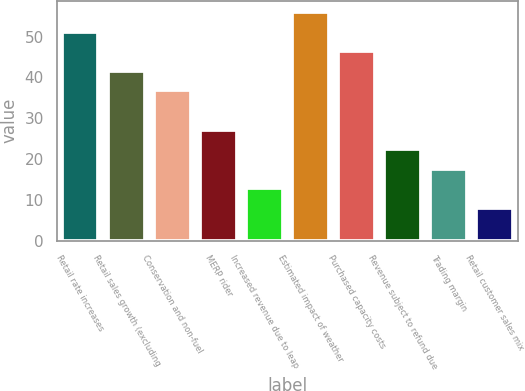Convert chart. <chart><loc_0><loc_0><loc_500><loc_500><bar_chart><fcel>Retail rate increases<fcel>Retail sales growth (excluding<fcel>Conservation and non-fuel<fcel>MERP rider<fcel>Increased revenue due to leap<fcel>Estimated impact of weather<fcel>Purchased capacity costs<fcel>Revenue subject to refund due<fcel>Trading margin<fcel>Retail customer sales mix<nl><fcel>51.2<fcel>41.6<fcel>36.8<fcel>27.2<fcel>12.8<fcel>56<fcel>46.4<fcel>22.4<fcel>17.6<fcel>8<nl></chart> 